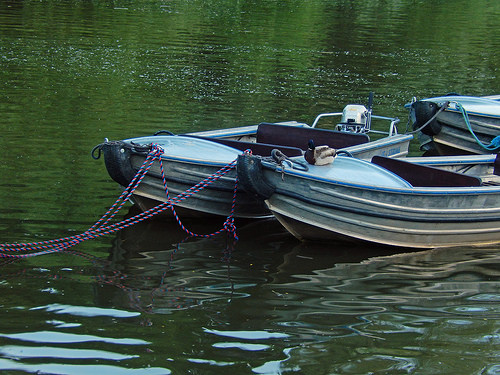<image>
Can you confirm if the mallard is on the boat? No. The mallard is not positioned on the boat. They may be near each other, but the mallard is not supported by or resting on top of the boat. 